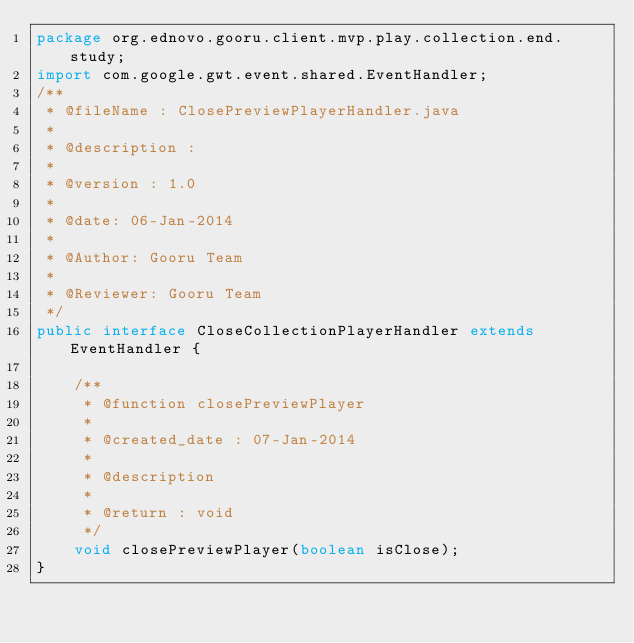Convert code to text. <code><loc_0><loc_0><loc_500><loc_500><_Java_>package org.ednovo.gooru.client.mvp.play.collection.end.study;
import com.google.gwt.event.shared.EventHandler;
/**
 * @fileName : ClosePreviewPlayerHandler.java
 *
 * @description : 
 *
 * @version : 1.0
 *
 * @date: 06-Jan-2014
 *
 * @Author: Gooru Team
 *
 * @Reviewer: Gooru Team
 */
public interface CloseCollectionPlayerHandler extends EventHandler {

	/**
	 * @function closePreviewPlayer 
	 * 
	 * @created_date : 07-Jan-2014
	 * 
	 * @description
	 * 
	 * @return : void
	 */
	void closePreviewPlayer(boolean isClose);
}
</code> 